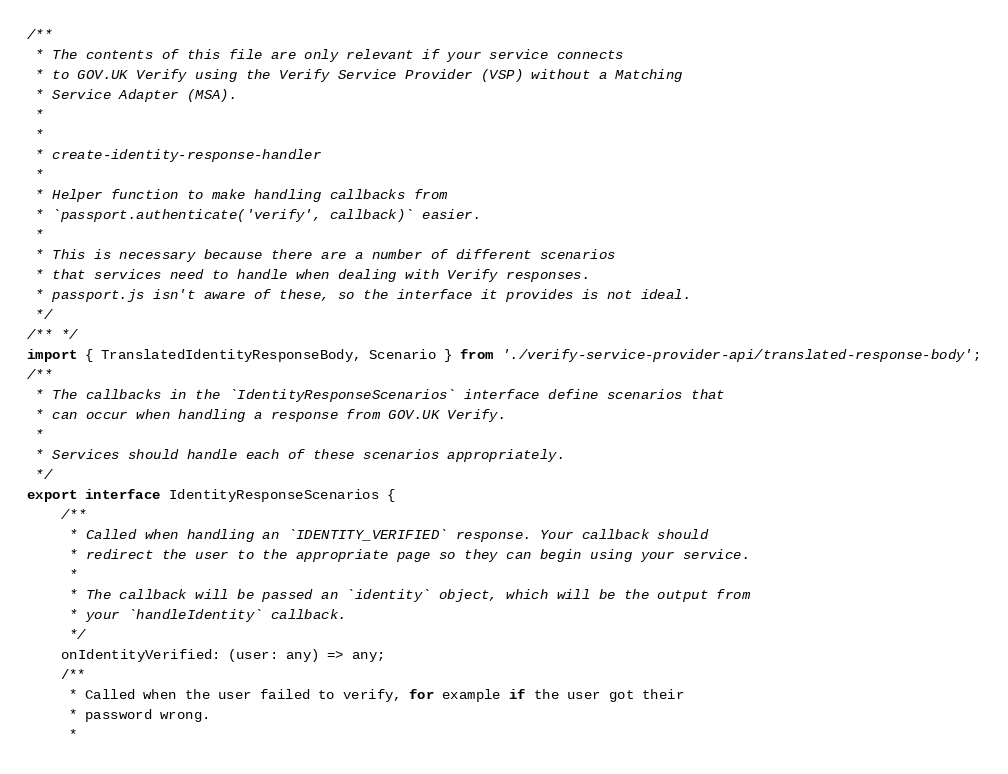<code> <loc_0><loc_0><loc_500><loc_500><_TypeScript_>/**
 * The contents of this file are only relevant if your service connects
 * to GOV.UK Verify using the Verify Service Provider (VSP) without a Matching
 * Service Adapter (MSA).
 *
 *
 * create-identity-response-handler
 *
 * Helper function to make handling callbacks from
 * `passport.authenticate('verify', callback)` easier.
 *
 * This is necessary because there are a number of different scenarios
 * that services need to handle when dealing with Verify responses.
 * passport.js isn't aware of these, so the interface it provides is not ideal.
 */
/** */
import { TranslatedIdentityResponseBody, Scenario } from './verify-service-provider-api/translated-response-body';
/**
 * The callbacks in the `IdentityResponseScenarios` interface define scenarios that
 * can occur when handling a response from GOV.UK Verify.
 *
 * Services should handle each of these scenarios appropriately.
 */
export interface IdentityResponseScenarios {
    /**
     * Called when handling an `IDENTITY_VERIFIED` response. Your callback should
     * redirect the user to the appropriate page so they can begin using your service.
     *
     * The callback will be passed an `identity` object, which will be the output from
     * your `handleIdentity` callback.
     */
    onIdentityVerified: (user: any) => any;
    /**
     * Called when the user failed to verify, for example if the user got their
     * password wrong.
     *</code> 